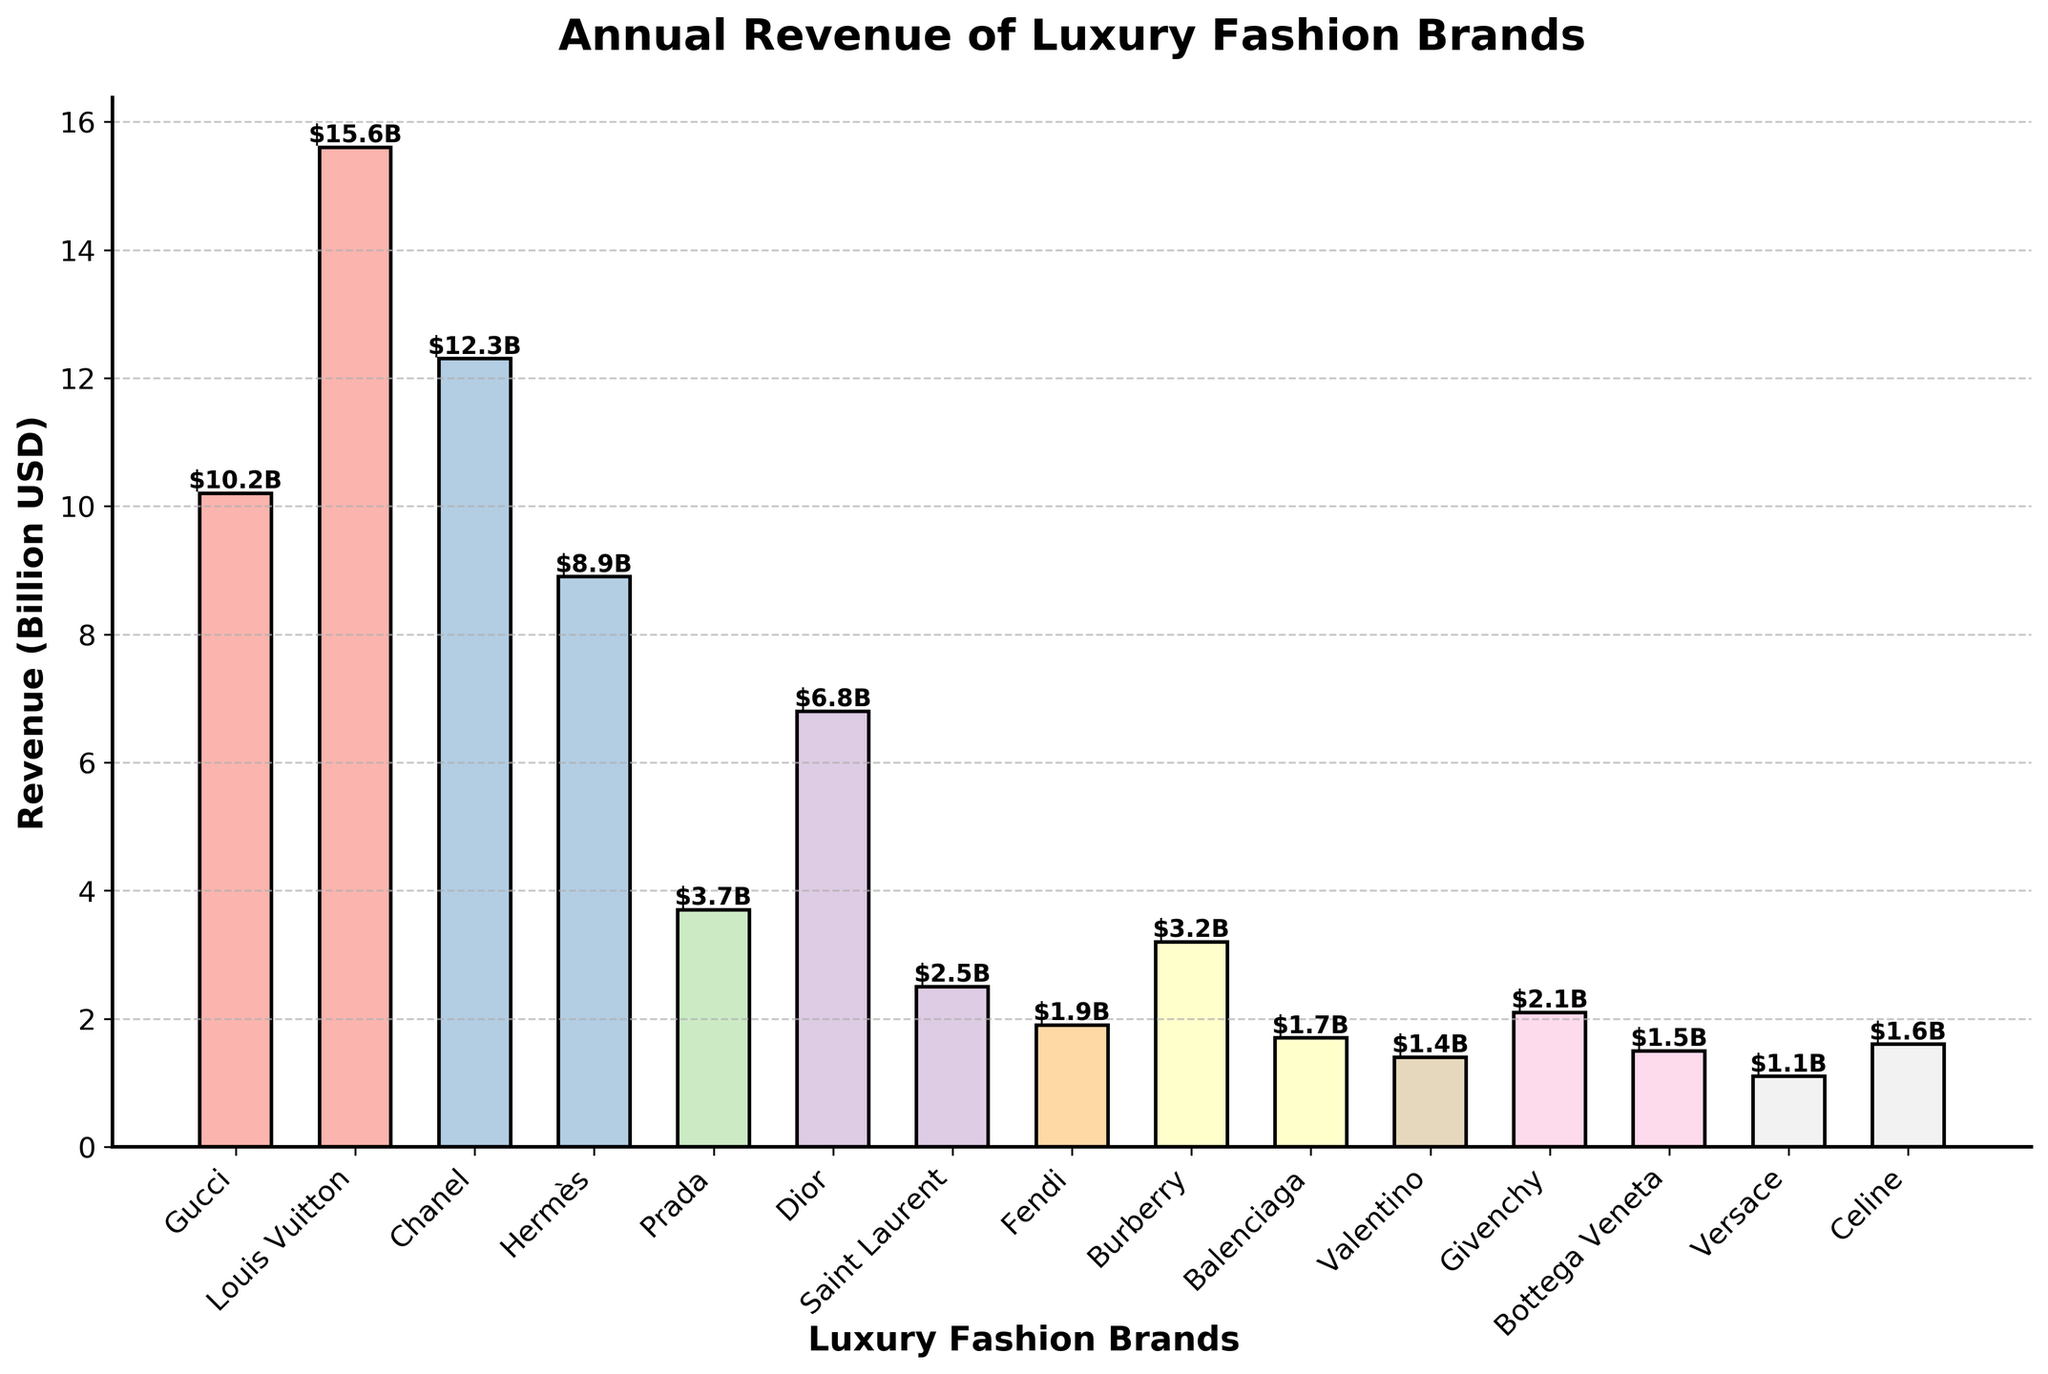What's the revenue of the brand with the shortest bar? First, identify the brand with the shortest bar, which is Versace. Then look at the height of Versace's bar to find the revenue.
Answer: $1.1B Which brand has the highest annual revenue, and what is the value? Look at the bars and identify the one with the greatest height. The tallest bar belongs to Louis Vuitton. Check the revenue value at the top of the bar.
Answer: Louis Vuitton, $15.6B What is the total revenue of the three brands with the highest annual revenue? Identify the three brands with the tallest bars: Louis Vuitton ($15.6B), Chanel ($12.3B), and Gucci ($10.2B). Sum these values: $15.6B + $12.3B + $10.2B.
Answer: $38.1B How does the revenue of Burberry compare to that of Prada? Find the heights of the bars for Burberry and Prada. Burberry has a revenue of $3.2B, whereas Prada has a revenue of $3.7B. Compare these two values.
Answer: Prada has a higher revenue by $0.5B What is the average revenue of Hermès, Dior, and Givenchy? Identify the revenues of Hermès ($8.9B), Dior ($6.8B), and Givenchy ($2.1B). Sum these values and divide by 3: ($8.9B + $6.8B + $2.1B) / 3.
Answer: $5.93B Compare the revenues of Saint Laurent and Balenciaga. Which is higher and by how much? Find the revenues of Saint Laurent ($2.5B) and Balenciaga ($1.7B). Subtract Balenciaga's revenue from Saint Laurent's revenue: $2.5B - $1.7B.
Answer: Saint Laurent by $0.8B Which brands have a revenue greater than $5B? Identify and list the brands with bars exceeding the $5B mark on the y-axis. These brands are Gucci, Louis Vuitton, Chanel, Hermès, and Dior.
Answer: Gucci, Louis Vuitton, Chanel, Hermès, Dior What is the total revenue of Givenchy, Bottega Veneta, and Celine? Identify the revenues of Givenchy ($2.1B), Bottega Veneta ($1.5B), and Celine ($1.6B). Sum these values: $2.1B + $1.5B + $1.6B.
Answer: $5.2B Which brand has a slightly higher revenue, Fendi or Valentino, and what is the difference? Find the revenues of Fendi ($1.9B) and Valentino ($1.4B). Subtract Valentino's revenue from Fendi's revenue: $1.9B - $1.4B.
Answer: Fendi by $0.5B 